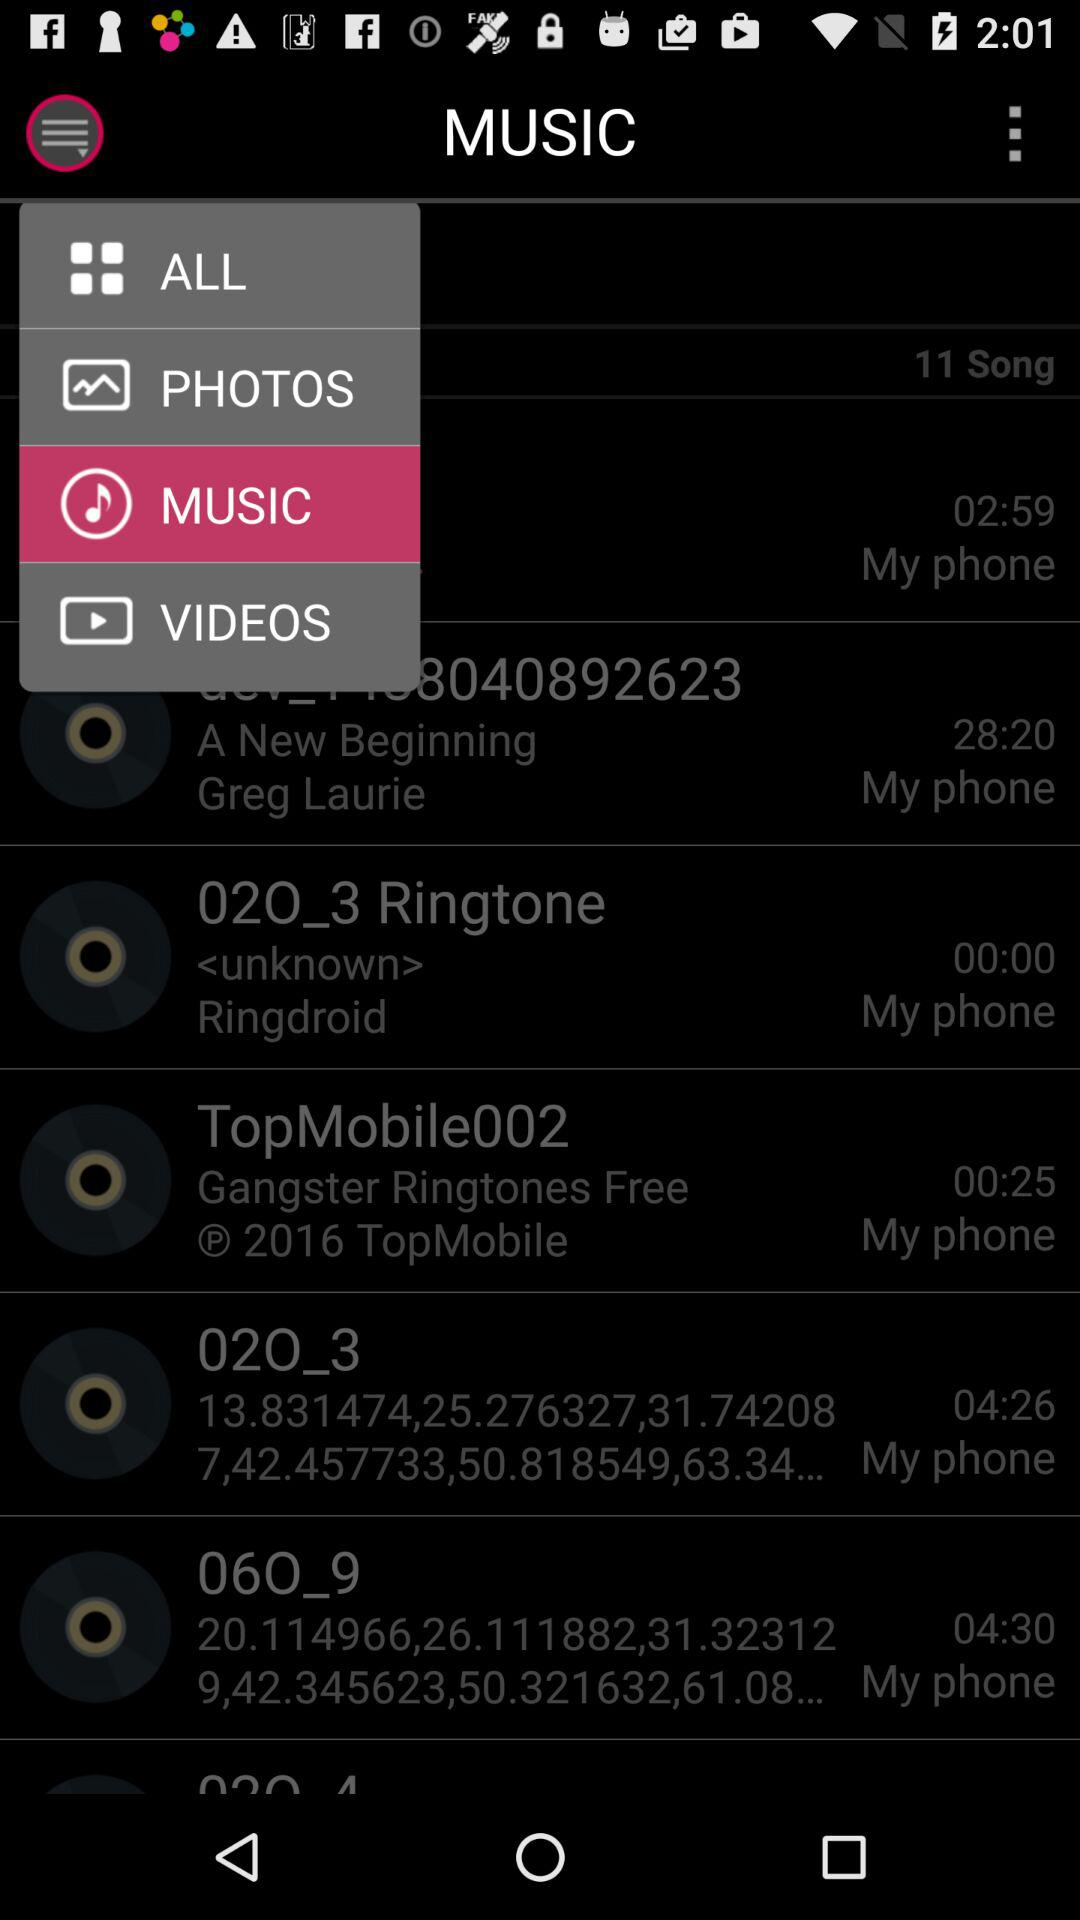How many songs in total are added? There are 11 songs in total that have been added. 